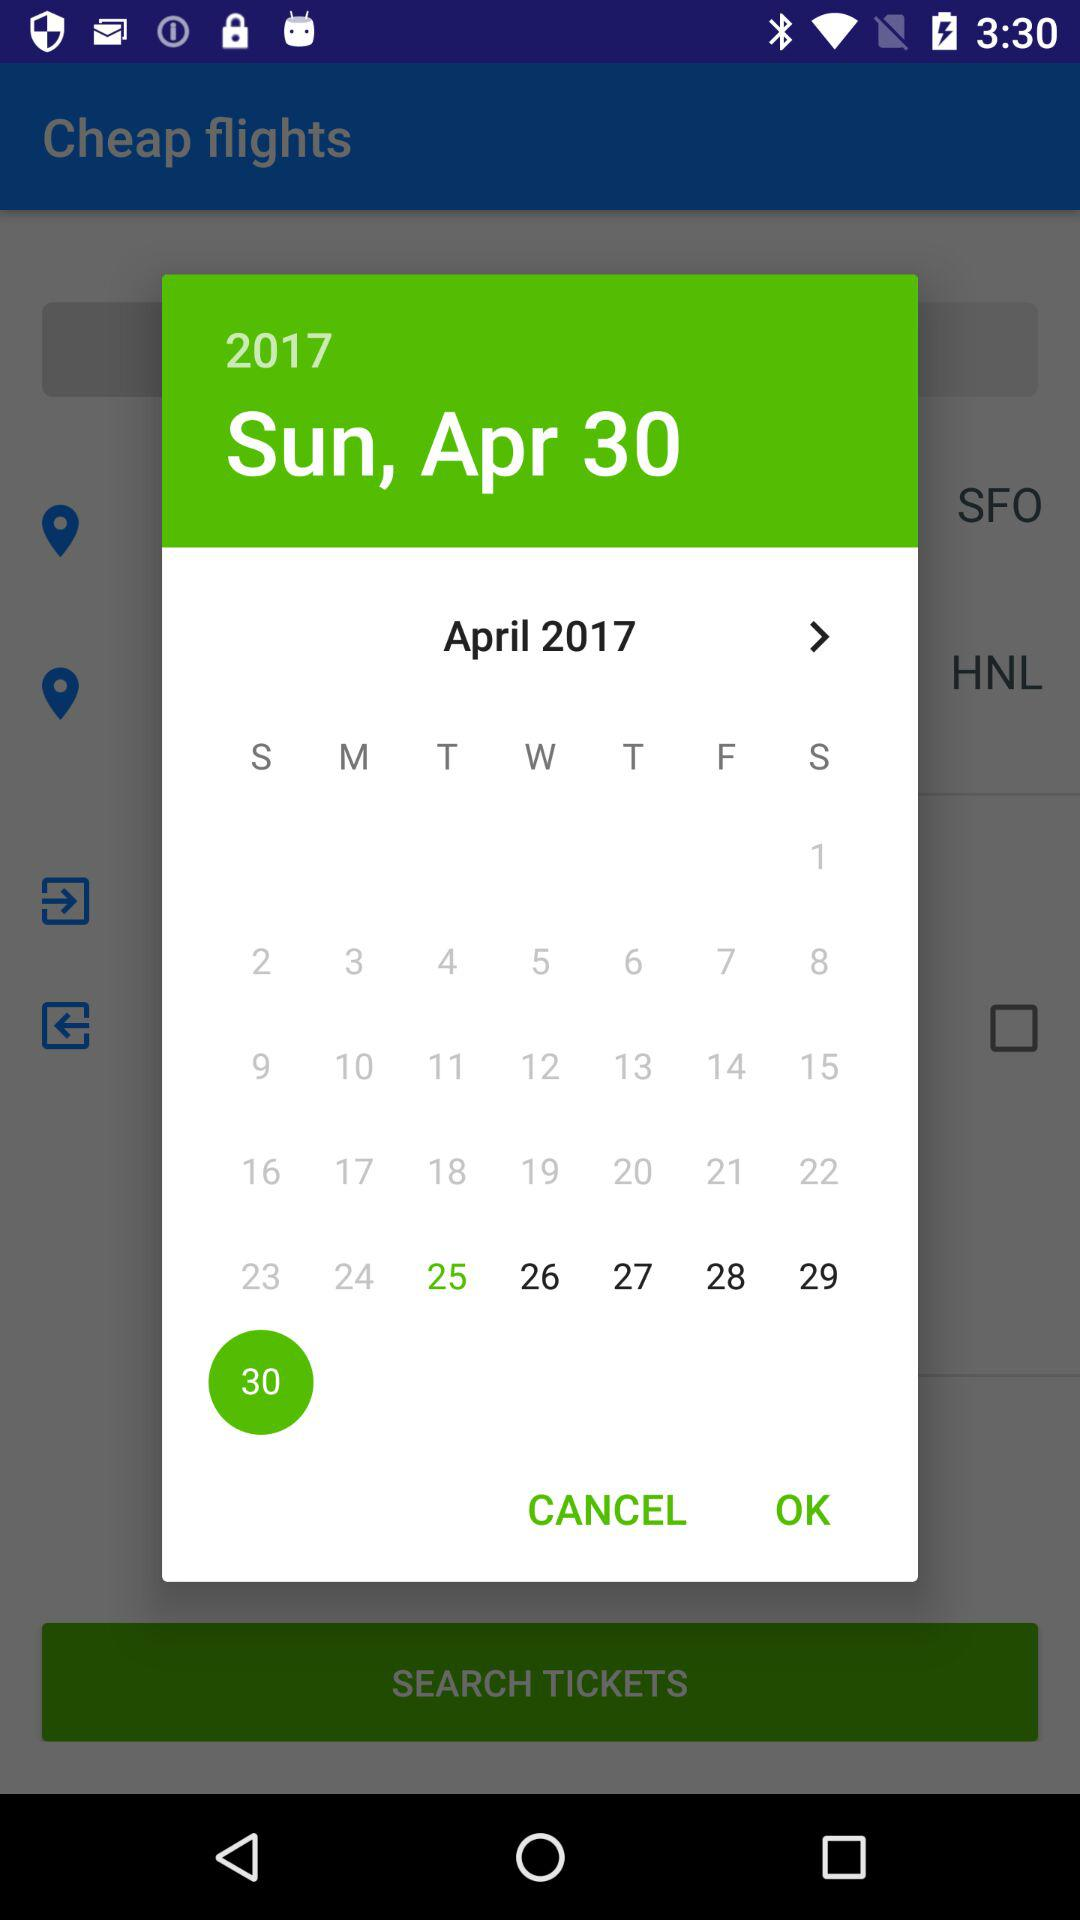What day is April 30th, 2017? The day is Sunday. 